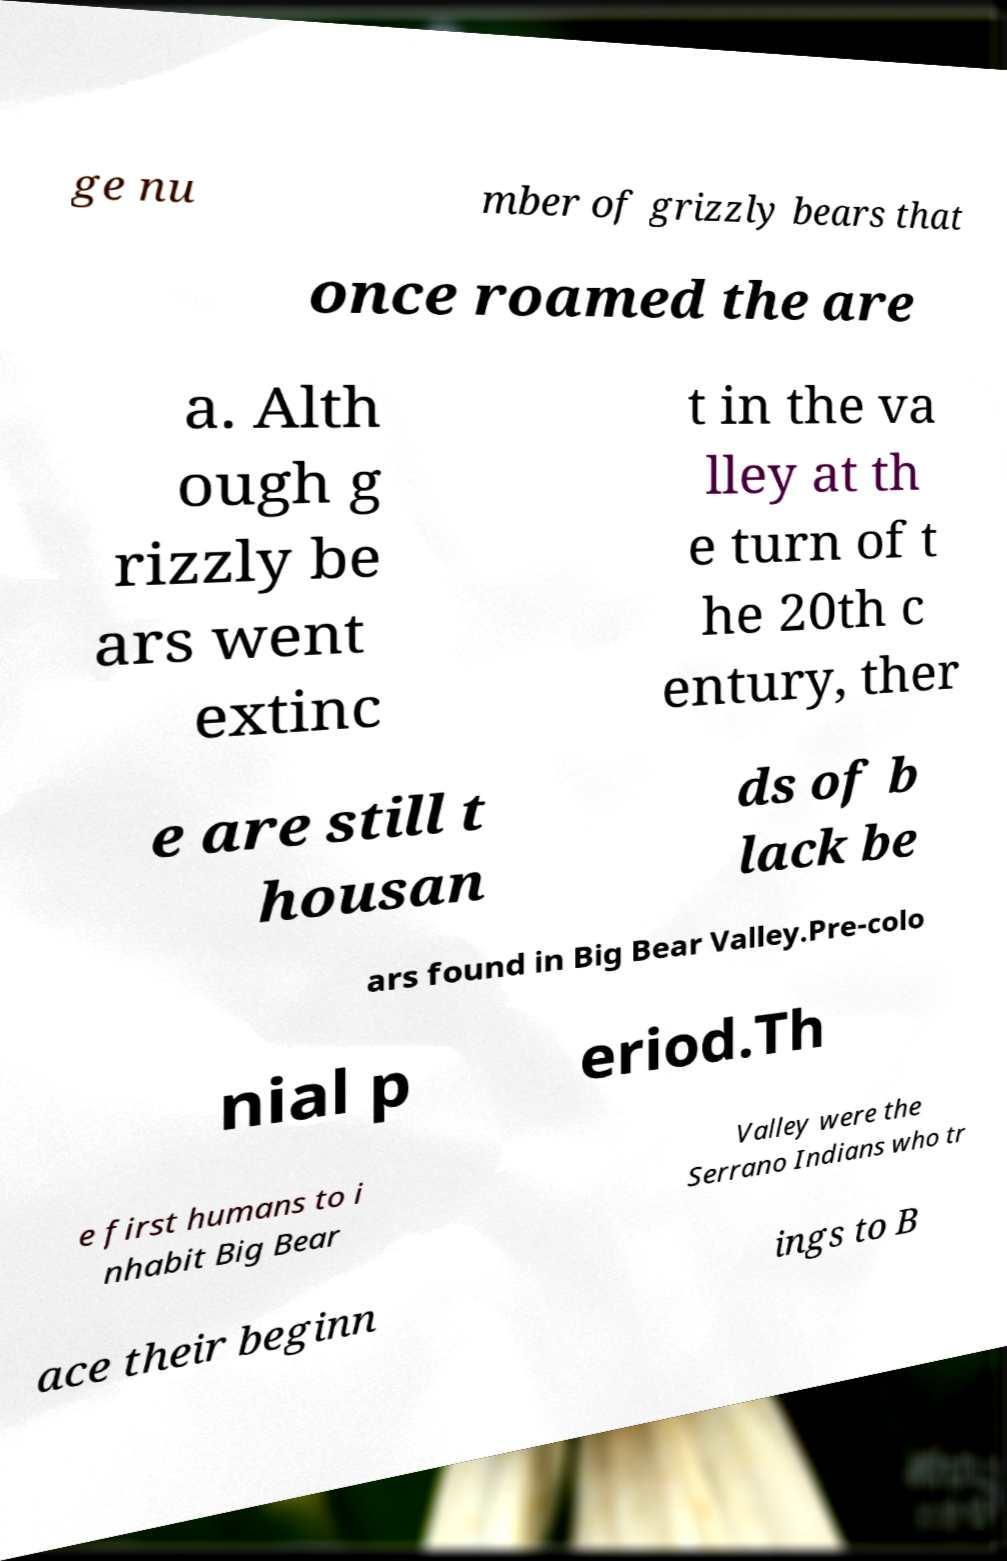Can you accurately transcribe the text from the provided image for me? ge nu mber of grizzly bears that once roamed the are a. Alth ough g rizzly be ars went extinc t in the va lley at th e turn of t he 20th c entury, ther e are still t housan ds of b lack be ars found in Big Bear Valley.Pre-colo nial p eriod.Th e first humans to i nhabit Big Bear Valley were the Serrano Indians who tr ace their beginn ings to B 